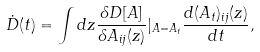Convert formula to latex. <formula><loc_0><loc_0><loc_500><loc_500>\dot { D } ( t ) = \int d z \frac { \delta D [ A ] } { \delta A _ { i j } ( z ) } | _ { A = A _ { t } } \frac { d ( A _ { t } ) _ { i j } ( z ) } { d t } ,</formula> 